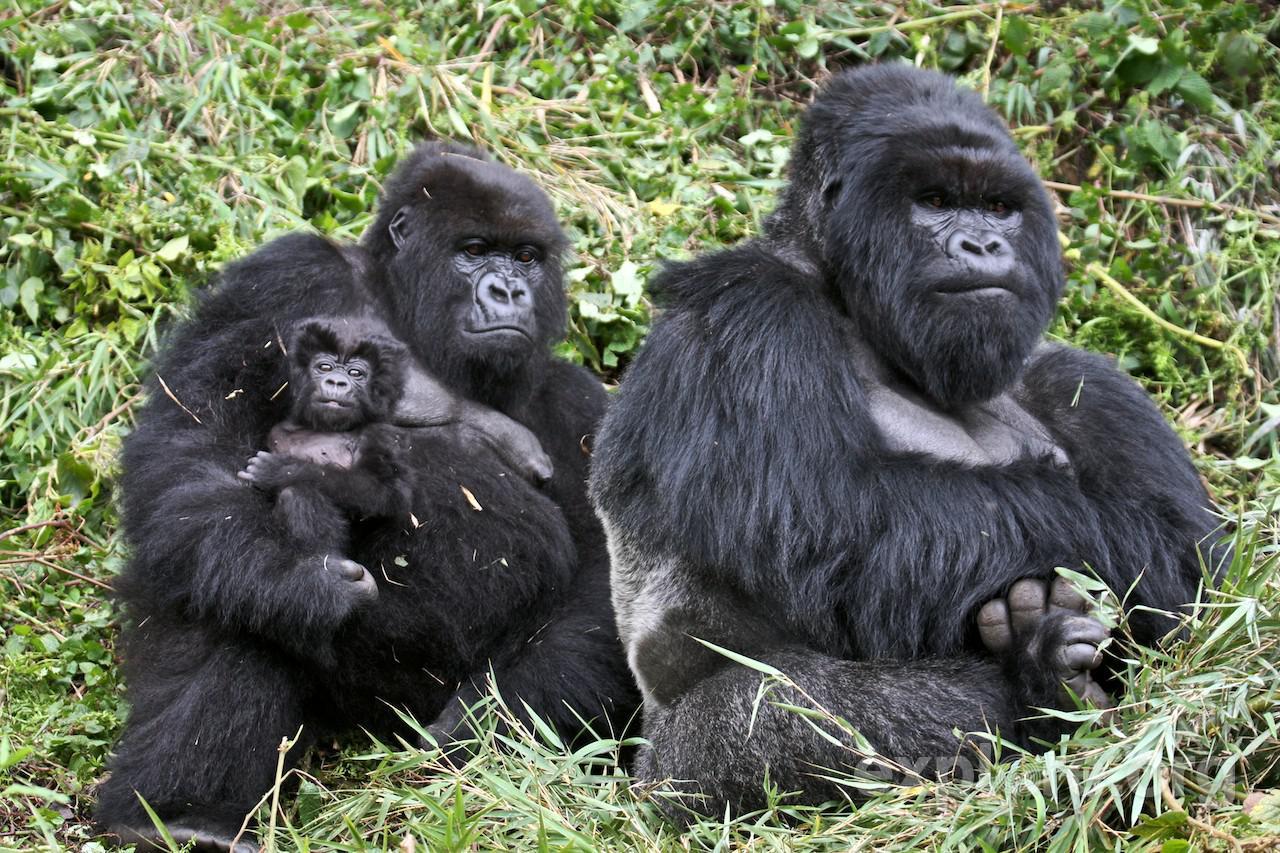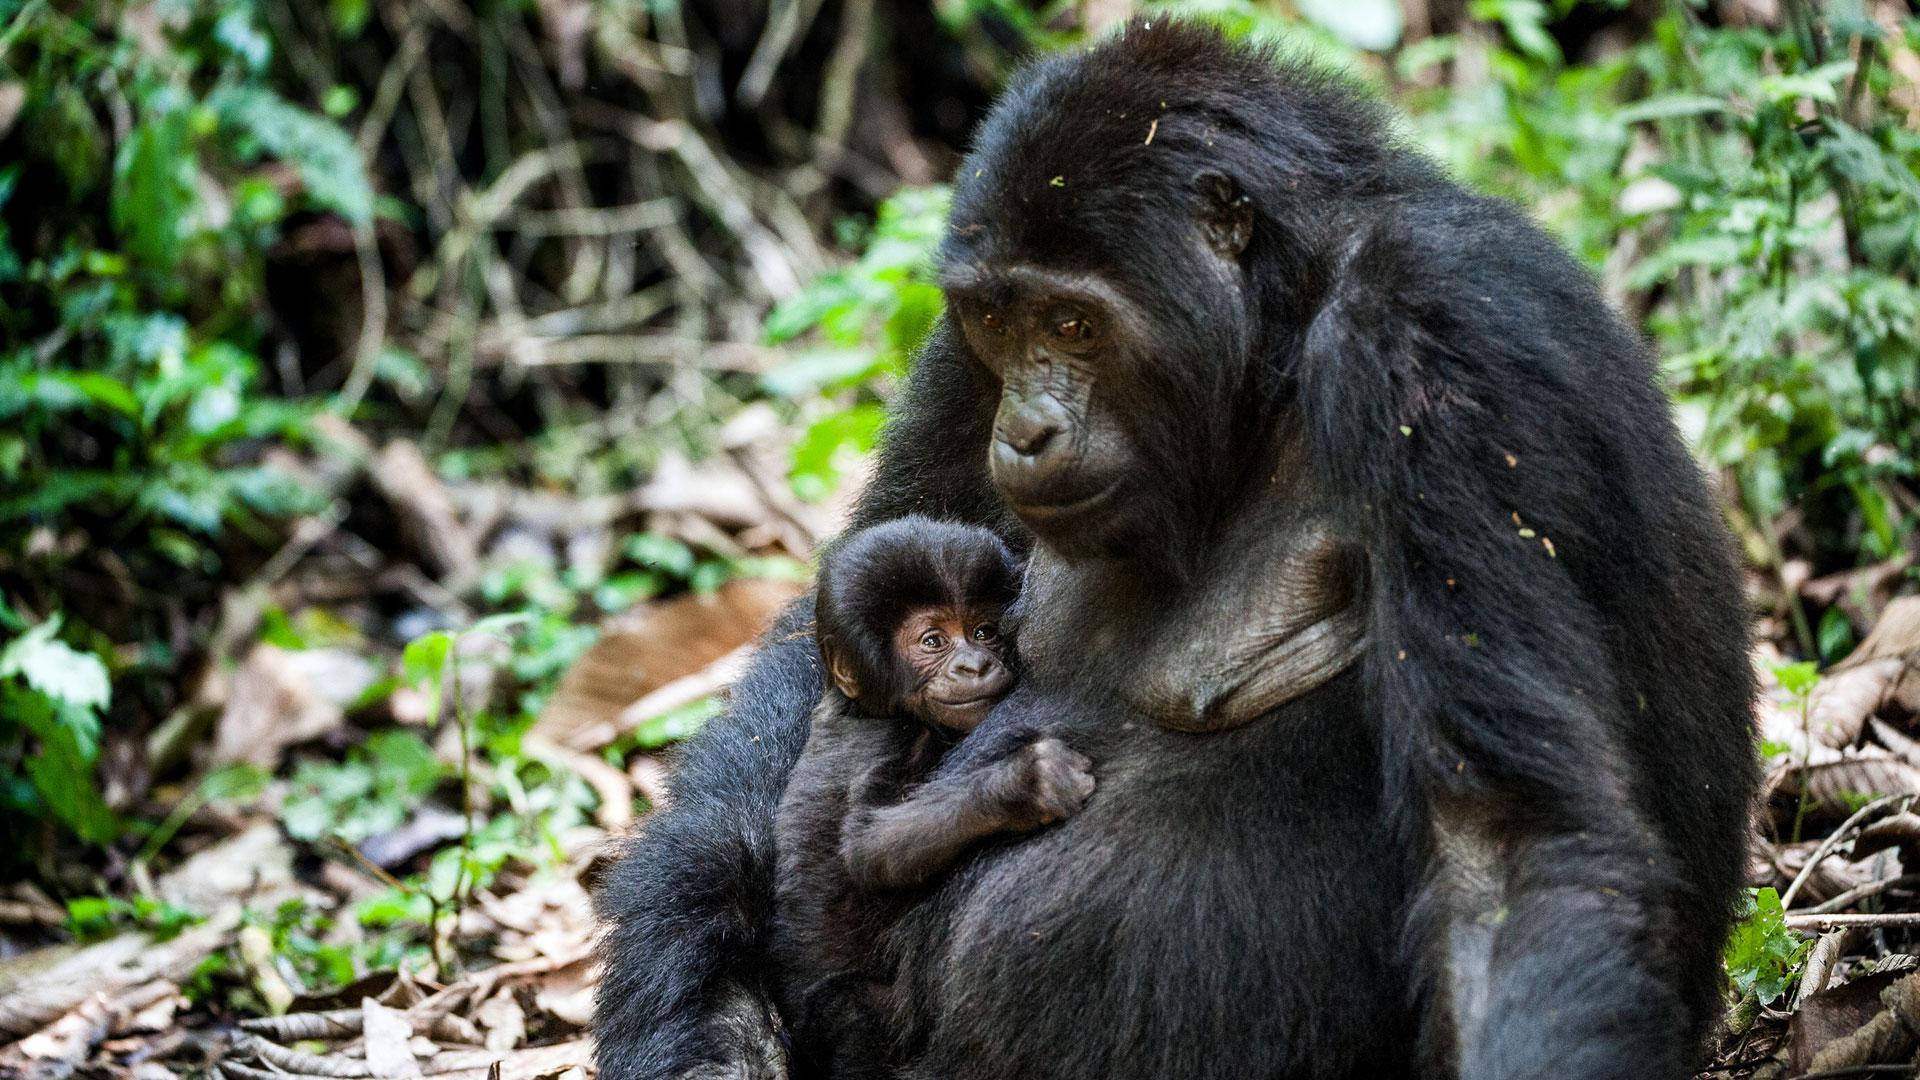The first image is the image on the left, the second image is the image on the right. Analyze the images presented: Is the assertion "Right image shows exactly two apes, a baby grasping an adult." valid? Answer yes or no. Yes. 